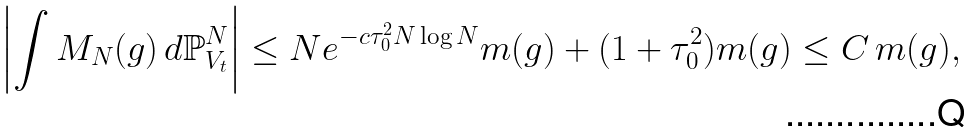<formula> <loc_0><loc_0><loc_500><loc_500>\left | \int M _ { N } ( g ) \, d \mathbb { P } ^ { N } _ { V _ { t } } \right | \leq N e ^ { - c \tau _ { 0 } ^ { 2 } N \log N } m ( g ) + ( 1 + \tau _ { 0 } ^ { 2 } ) m ( g ) \leq C \, m ( g ) ,</formula> 